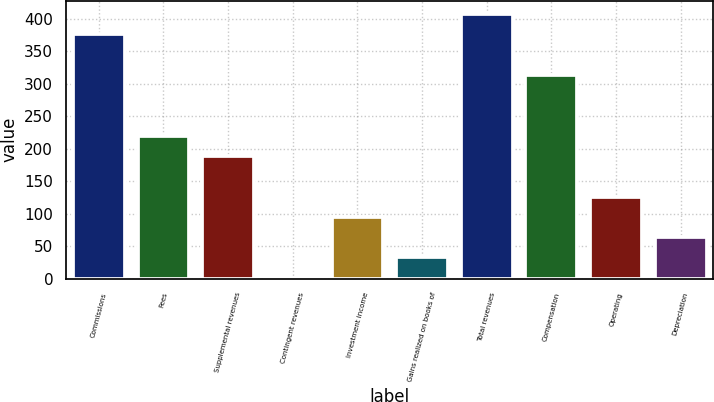Convert chart to OTSL. <chart><loc_0><loc_0><loc_500><loc_500><bar_chart><fcel>Commissions<fcel>Fees<fcel>Supplemental revenues<fcel>Contingent revenues<fcel>Investment income<fcel>Gains realized on books of<fcel>Total revenues<fcel>Compensation<fcel>Operating<fcel>Depreciation<nl><fcel>375.88<fcel>219.93<fcel>188.74<fcel>1.6<fcel>95.17<fcel>32.79<fcel>407.07<fcel>313.5<fcel>126.36<fcel>63.98<nl></chart> 